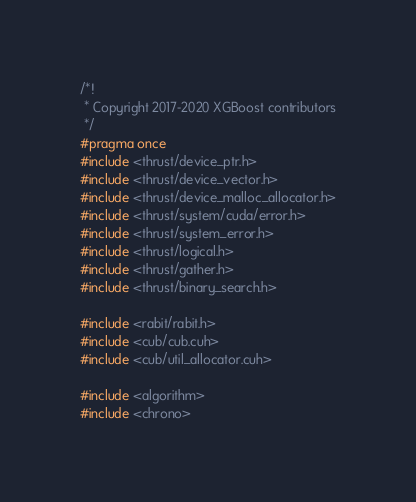Convert code to text. <code><loc_0><loc_0><loc_500><loc_500><_Cuda_>/*!
 * Copyright 2017-2020 XGBoost contributors
 */
#pragma once
#include <thrust/device_ptr.h>
#include <thrust/device_vector.h>
#include <thrust/device_malloc_allocator.h>
#include <thrust/system/cuda/error.h>
#include <thrust/system_error.h>
#include <thrust/logical.h>
#include <thrust/gather.h>
#include <thrust/binary_search.h>

#include <rabit/rabit.h>
#include <cub/cub.cuh>
#include <cub/util_allocator.cuh>

#include <algorithm>
#include <chrono></code> 